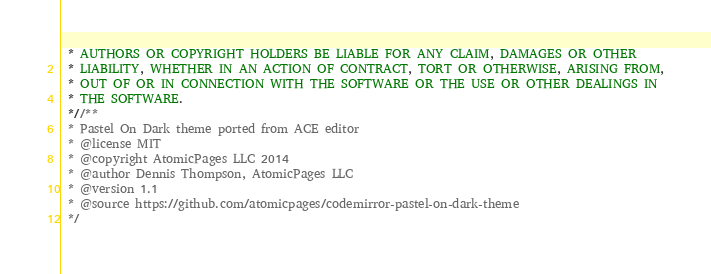Convert code to text. <code><loc_0><loc_0><loc_500><loc_500><_CSS_> * AUTHORS OR COPYRIGHT HOLDERS BE LIABLE FOR ANY CLAIM, DAMAGES OR OTHER
 * LIABILITY, WHETHER IN AN ACTION OF CONTRACT, TORT OR OTHERWISE, ARISING FROM,
 * OUT OF OR IN CONNECTION WITH THE SOFTWARE OR THE USE OR OTHER DEALINGS IN
 * THE SOFTWARE.
 *//**
 * Pastel On Dark theme ported from ACE editor
 * @license MIT
 * @copyright AtomicPages LLC 2014
 * @author Dennis Thompson, AtomicPages LLC
 * @version 1.1
 * @source https://github.com/atomicpages/codemirror-pastel-on-dark-theme
 */</code> 